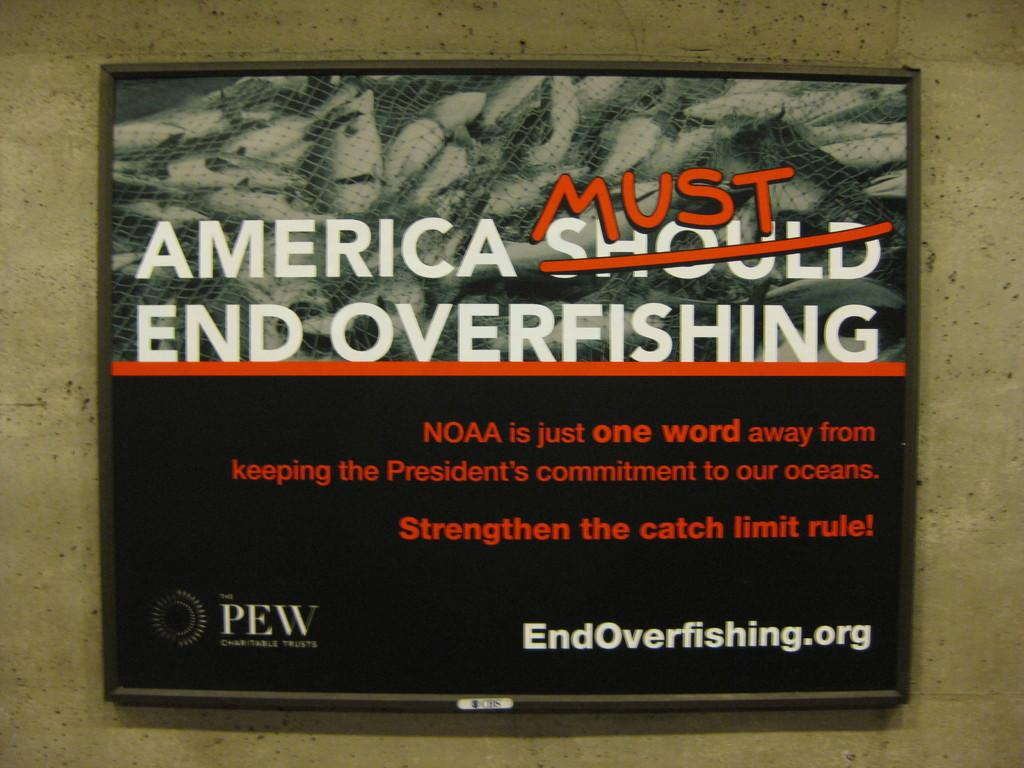<image>
Write a terse but informative summary of the picture. A sign on a wall that reads America must end overfishing. 